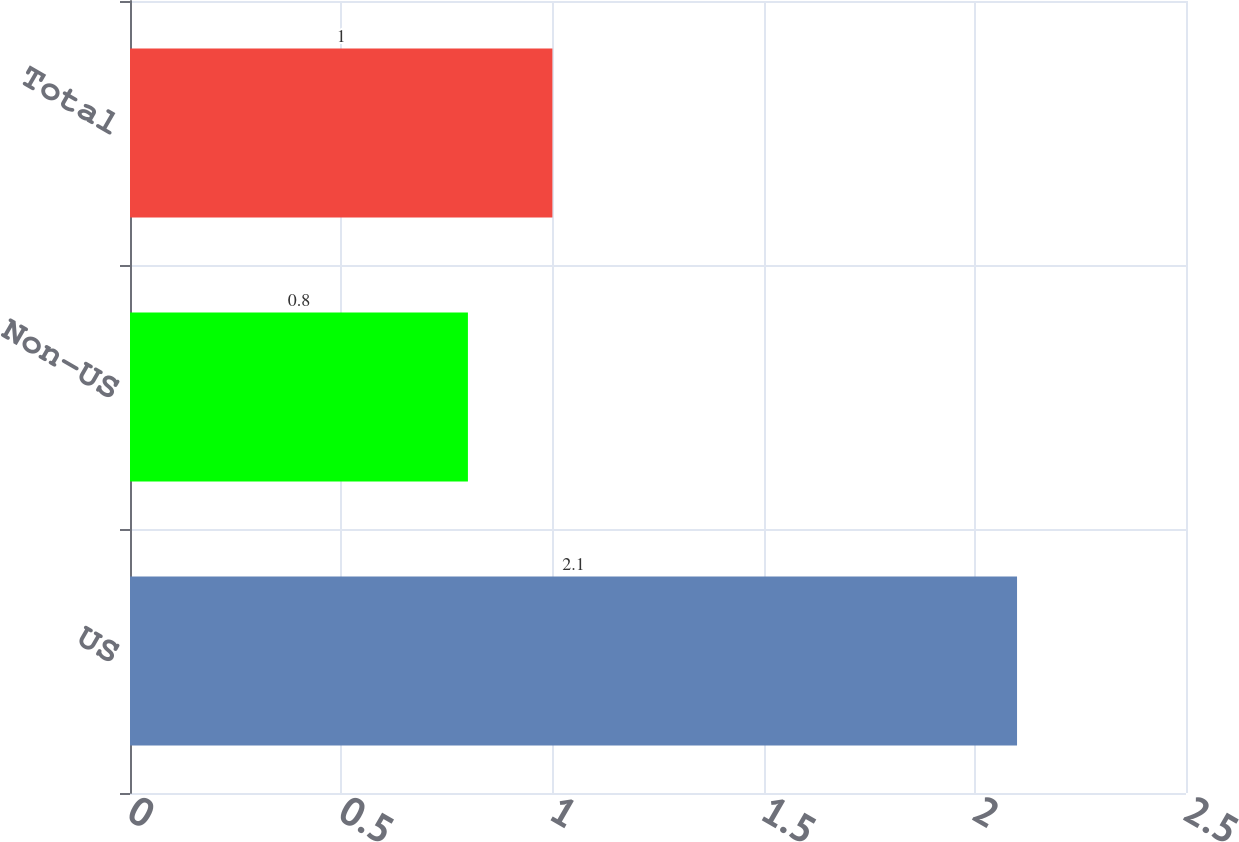Convert chart to OTSL. <chart><loc_0><loc_0><loc_500><loc_500><bar_chart><fcel>US<fcel>Non-US<fcel>Total<nl><fcel>2.1<fcel>0.8<fcel>1<nl></chart> 